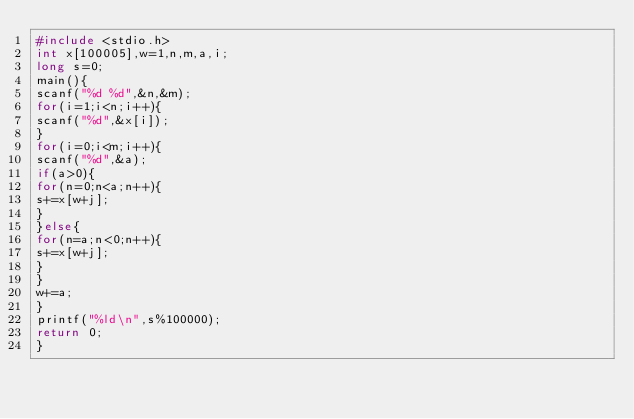<code> <loc_0><loc_0><loc_500><loc_500><_C_>#include <stdio.h>
int x[100005],w=1,n,m,a,i;
long s=0;
main(){
scanf("%d %d",&n,&m);
for(i=1;i<n;i++){
scanf("%d",&x[i]);
}
for(i=0;i<m;i++){
scanf("%d",&a);
if(a>0){
for(n=0;n<a;n++){
s+=x[w+j];
}
}else{
for(n=a;n<0;n++){
s+=x[w+j];
}
}
w+=a;
}
printf("%ld\n",s%100000);
return 0;
}</code> 